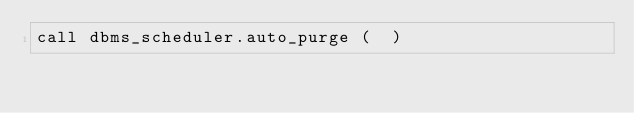<code> <loc_0><loc_0><loc_500><loc_500><_SQL_>call dbms_scheduler.auto_purge (  )
</code> 